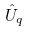<formula> <loc_0><loc_0><loc_500><loc_500>\hat { U } _ { q }</formula> 